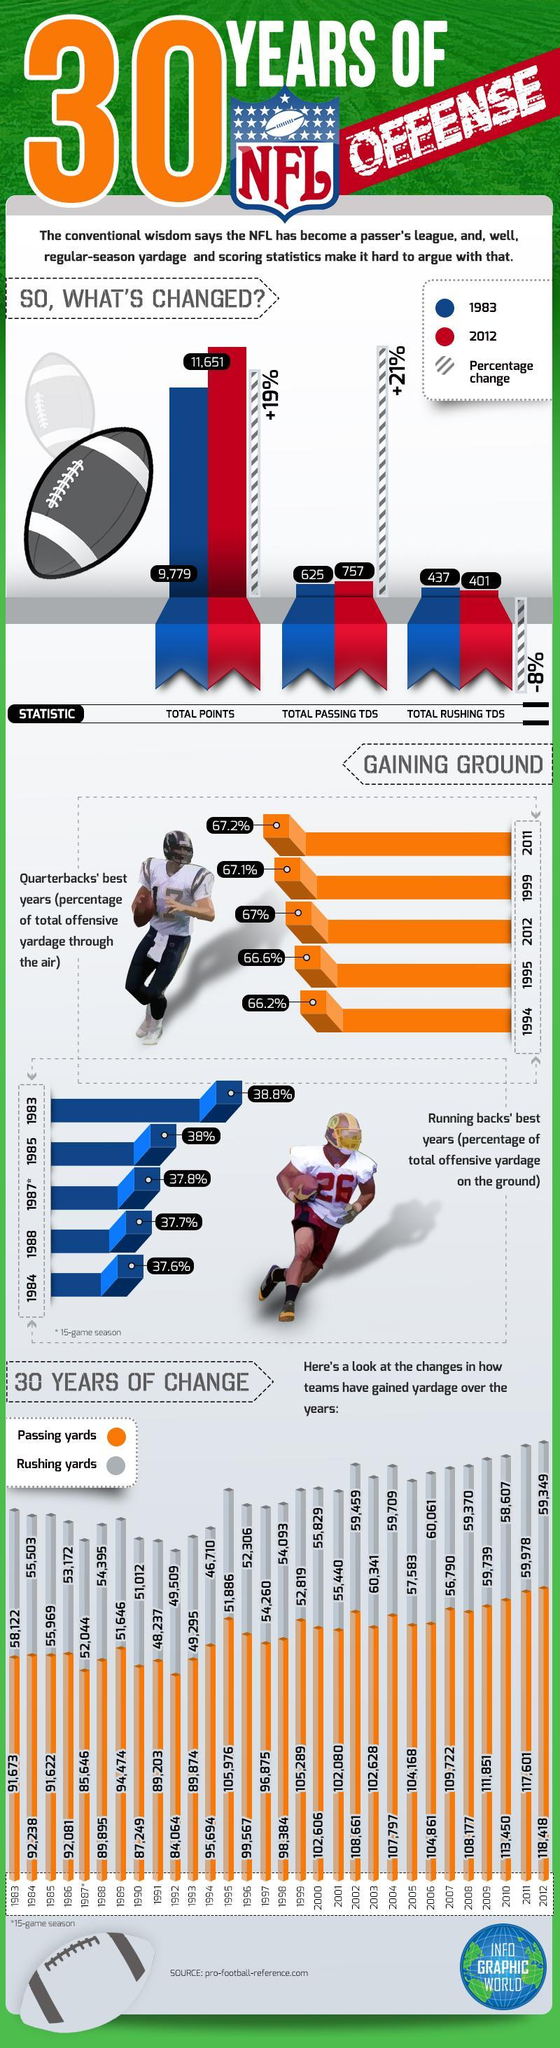What is the total passing TDS in the NFL games in 2012?
Answer the question with a short phrase. 757 What is the percentage change in the total passing TDS in the NFL games from 1983 to 2012? +21% What is the percentage change in the total points scored in the NFL games from 1983 to 2012? +19% What is the percentage of total offensive yardage through the air in 2012? 67% What is the percentage of total offensive yardage on the ground in 1985? 38% What is the total rushing TDS in the NFL games in 1983? 437 